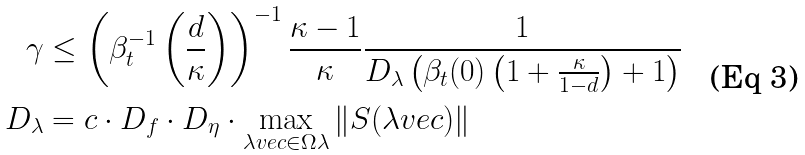<formula> <loc_0><loc_0><loc_500><loc_500>\gamma & \leq \left ( \beta _ { t } ^ { - 1 } \left ( \frac { d } { \kappa } \right ) \right ) ^ { - 1 } \frac { \kappa - 1 } { \kappa } \frac { 1 } { D _ { \lambda } \left ( \beta _ { t } ( 0 ) \left ( 1 + \frac { \kappa } { 1 - d } \right ) + 1 \right ) } \\ D _ { \lambda } & = c \cdot D _ { f } \cdot D _ { \eta } \cdot \max _ { \lambda v e c \in \Omega \lambda } \| S ( \lambda v e c ) \|</formula> 